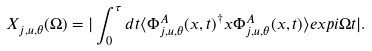<formula> <loc_0><loc_0><loc_500><loc_500>X _ { j , u , \theta } ( \Omega ) = | \int _ { 0 } ^ { \tau } d t \langle \Phi _ { j , u , \theta } ^ { A } ( x , t ) ^ { \dagger } x \Phi _ { j , u , \theta } ^ { A } ( x , t ) \rangle e x p i \Omega t | .</formula> 